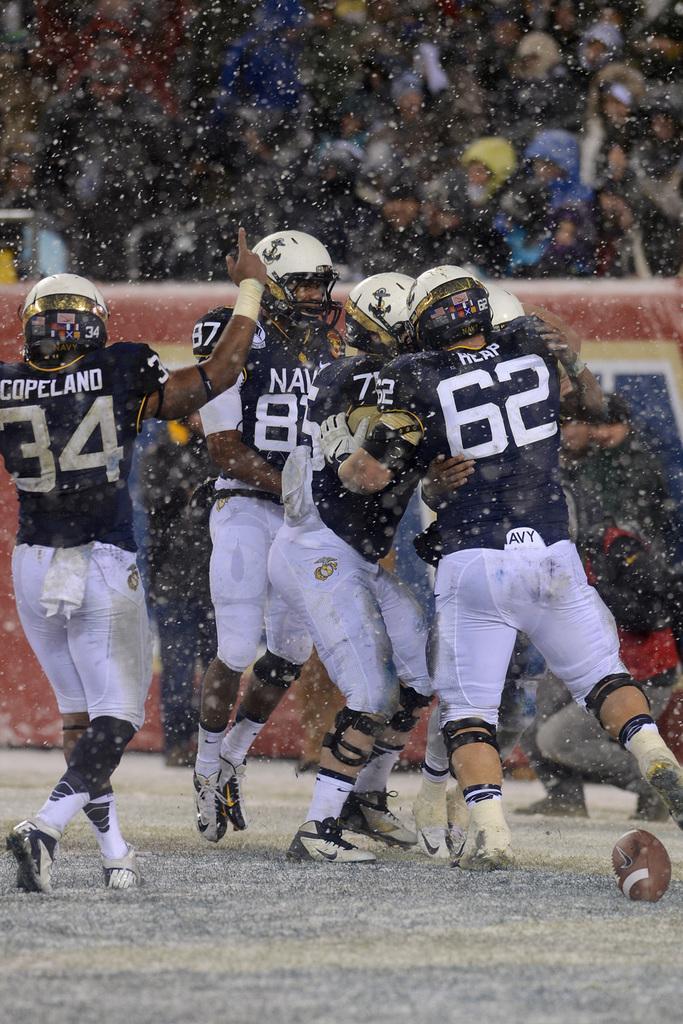In one or two sentences, can you explain what this image depicts? In the picture there are many people present on the ground, they are wearing the same costume and helmets, behind them there is a wall, behind the wall there are people present. 